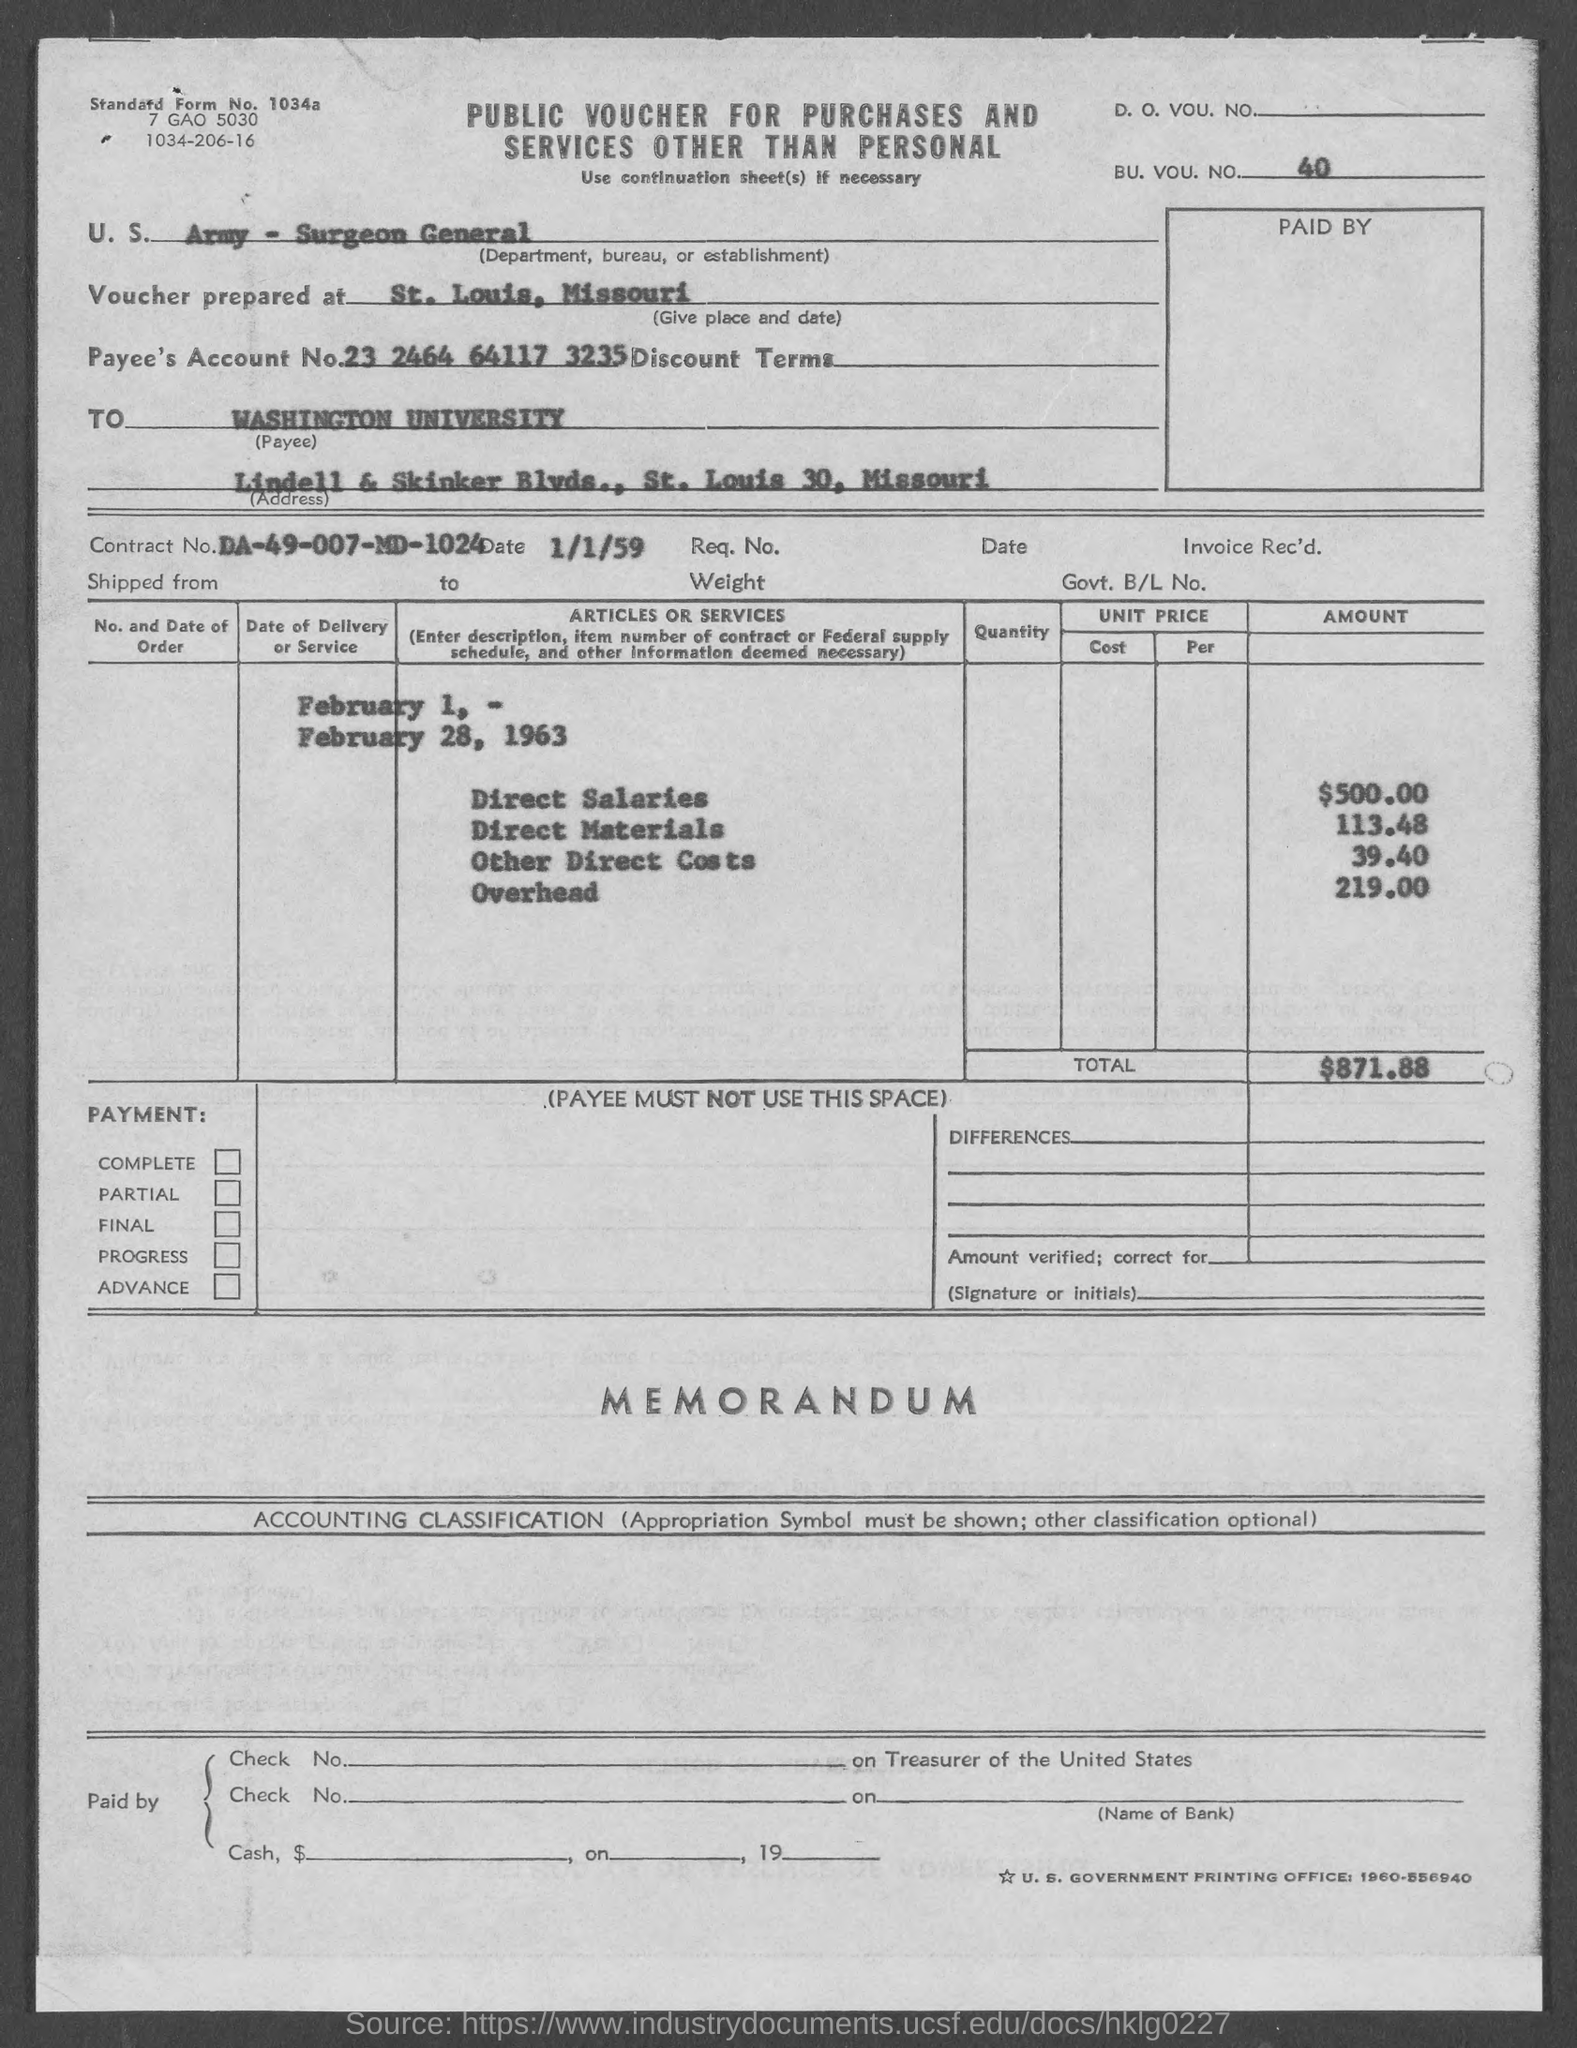Draw attention to some important aspects in this diagram. The voucher mentions a BU. VOU. NO. of 40. The direct salaries cost mentioned in the voucher is 500.00. The voucher was prepared at St. Louis, Missouri. The Contract No. given in the voucher is DA-49-007-MD-1024. The voucher mentions a total amount of $871.88. 